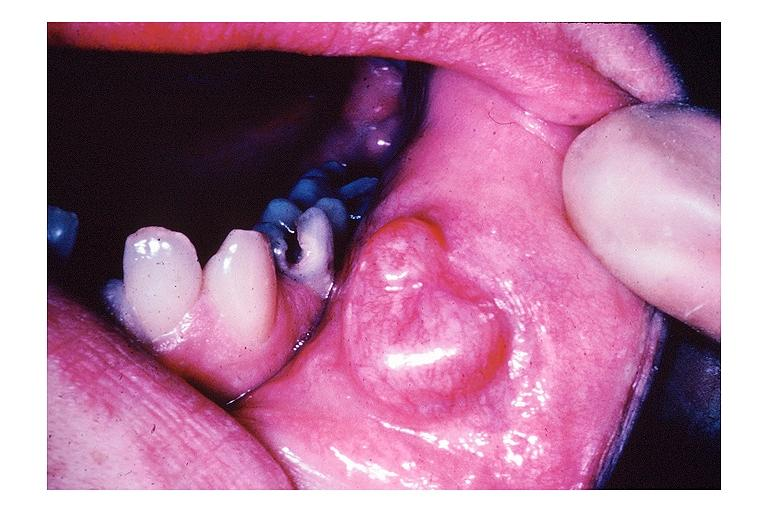what does this image show?
Answer the question using a single word or phrase. Mucocele 